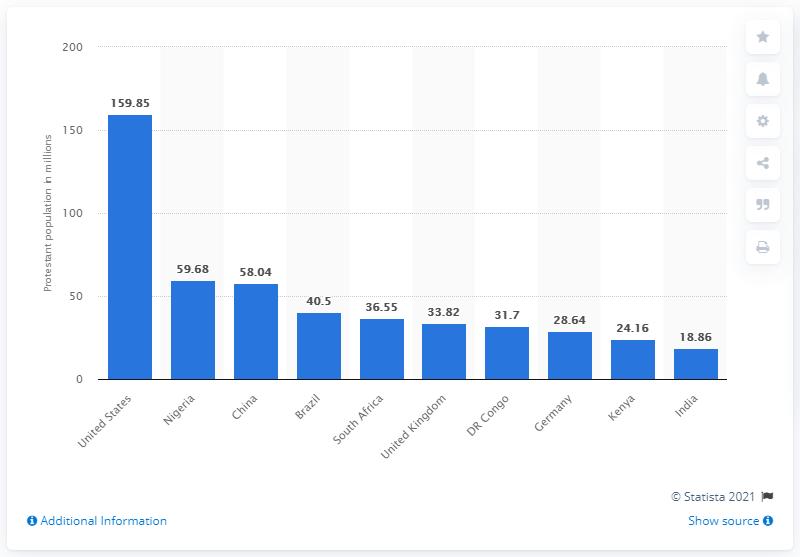Specify some key components in this picture. In 2010, it is estimated that approximately 159.85 million people in the United States identified as Protestant. 